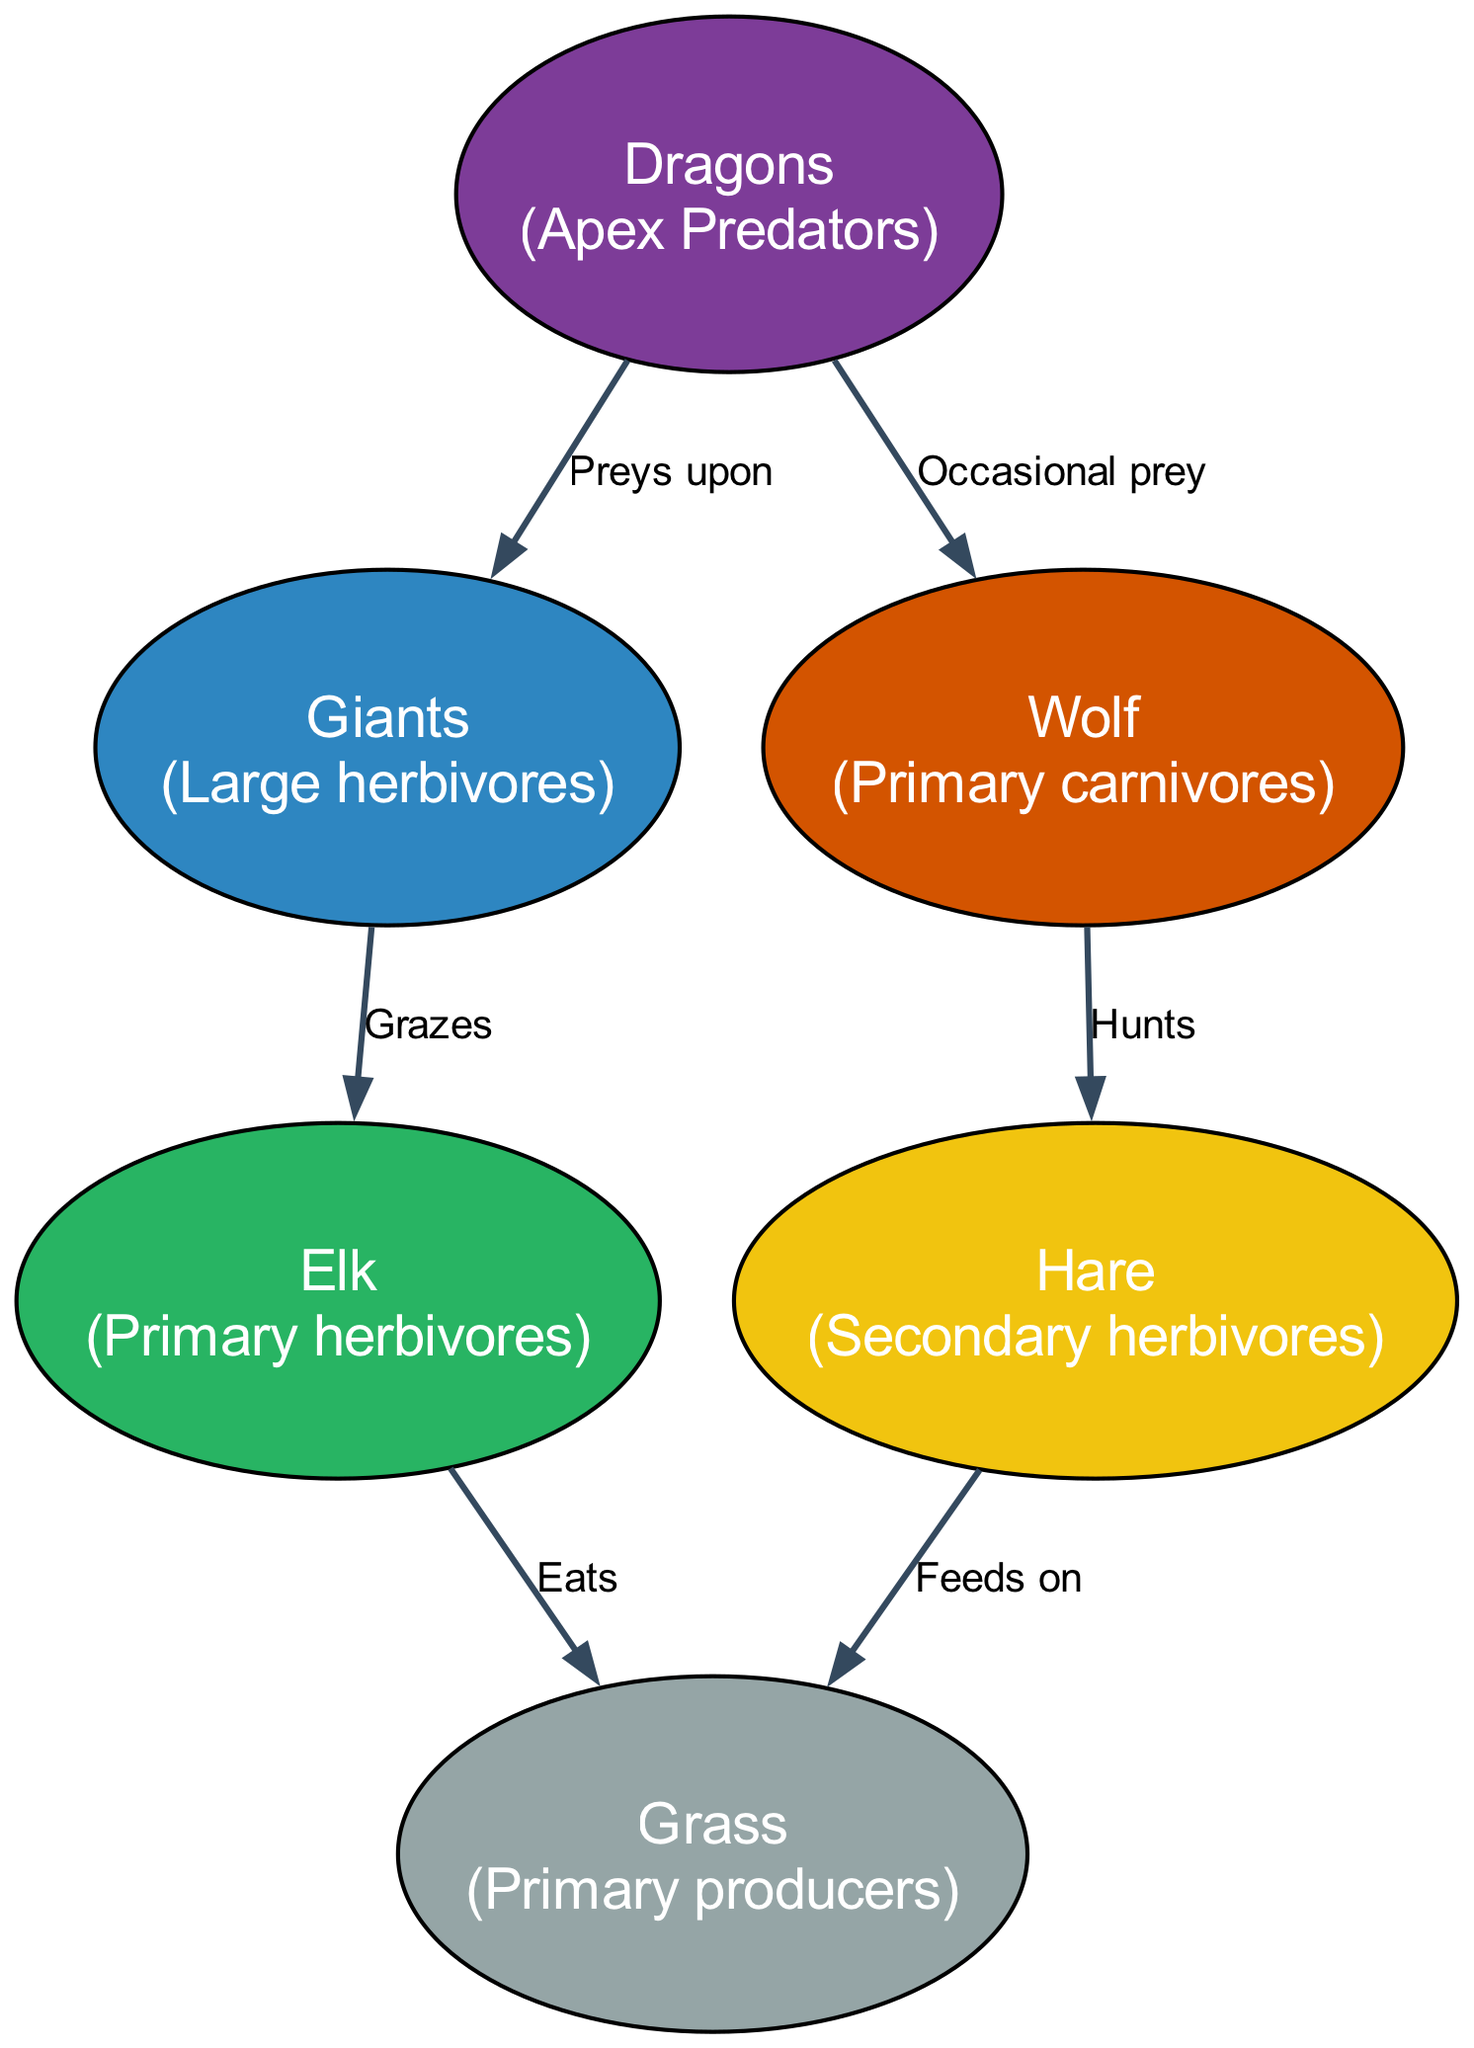What are the apex predators in this food chain? According to the diagram, the apex predators are represented by the node labeled "Dragons." Since they prey upon other creatures, this classification indicates their top position in the food chain.
Answer: Dragons How many nodes are there in total? The diagram features six nodes: Dragons, Giants, Elk, Wolf, Hare, and Grass. To find this number, I simply counted all unique nodes present in the diagram.
Answer: 6 What do Giants graze on? The directed edge from "Giants" leads to "Elk" and is labeled "Grazes," indicating that Giants feed on Elk in this food chain. Thus, the answer is found directly by examining the relationship established in the diagram.
Answer: Elk Which herbivores are categorized as primary? The primary herbivores mentioned in the diagram are specifically identified as "Elk." By referencing the description for this node and its connections, I confirm it as a primary species within the herbivore category.
Answer: Elk What happens to the Grass according to the food chain? Grass is identified as the primary producer in the ecosystem. It is consumed by both the Elk and the Hare, as indicated by the arrows leading from Elk and Hare to Grass. Thus, Grass is a fundamental resource in this food chain.
Answer: Eats What animal hunts the Hare? The diagram shows that "Wolf," represented as a primary carnivore, has a directed edge labeled "Hunts" pointing to "Hare." This indicates that the Wolf preys on the Hare as per the food chain's structure.
Answer: Wolf Which creature occasionally becomes prey for Dragons? The edge representation from "Dragons" to "Wolf" labeled "Occasional prey" signifies that Wolves occasionally fall victim to the Dragons, giving us the answer directly reflected in the connections of the food chain.
Answer: Wolf How many edges connect the nodes in the diagram? There are a total of six directed edges in the food chain diagram. To determine this number, I counted each line of connection listed in the edges section of the diagram.
Answer: 6 